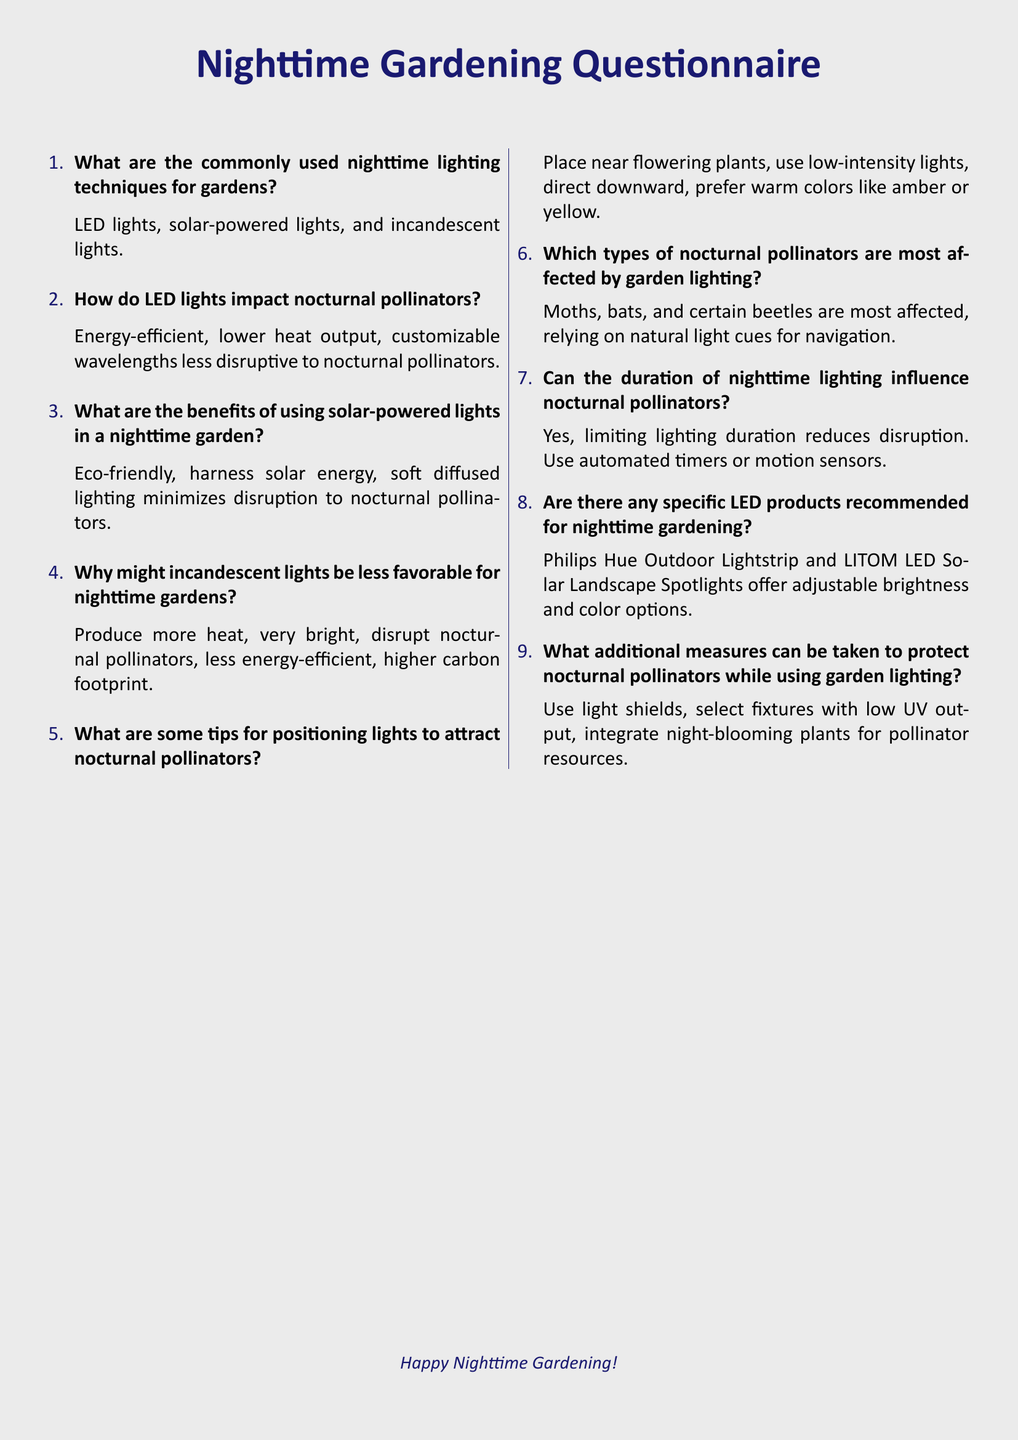What are the commonly used nighttime lighting techniques for gardens? The document lists the commonly used nighttime lighting techniques for gardens, which include LED lights, solar-powered lights, and incandescent lights.
Answer: LED lights, solar-powered lights, and incandescent lights How do LED lights impact nocturnal pollinators? The document explains that LED lights are energy-efficient, produce lower heat output, and have customizable wavelengths that are less disruptive to nocturnal pollinators.
Answer: Energy-efficient, lower heat output, customizable wavelengths What are the benefits of using solar-powered lights in a nighttime garden? According to the document, the benefits of using solar-powered lights include being eco-friendly, harnessing solar energy, and providing soft diffused lighting that minimizes disruption to nocturnal pollinators.
Answer: Eco-friendly, harness solar energy, soft diffused lighting Why might incandescent lights be less favorable for nighttime gardens? The document states that incandescent lights produce more heat, are very bright, disrupt nocturnal pollinators, are less energy-efficient, and have a higher carbon footprint.
Answer: Produce more heat, very bright, disrupt nocturnal pollinators Which types of nocturnal pollinators are most affected by garden lighting? The document specifically mentions that moths, bats, and certain beetles are most affected by garden lighting as they rely on natural light cues for navigation.
Answer: Moths, bats, and certain beetles Can the duration of nighttime lighting influence nocturnal pollinators? The questionnaire indicates that limiting the duration of nighttime lighting reduces disruption to nocturnal pollinators, suggesting the use of automated timers or motion sensors.
Answer: Yes, limiting lighting duration reduces disruption Are there any specific LED products recommended for nighttime gardening? The document recommends specific LED products such as Philips Hue Outdoor Lightstrip and LITOM LED Solar Landscape Spotlights for nighttime gardening.
Answer: Philips Hue Outdoor Lightstrip and LITOM LED Solar Landscape Spotlights What additional measures can be taken to protect nocturnal pollinators while using garden lighting? The document mentions using light shields, selecting fixtures with low UV output, and integrating night-blooming plants as additional measures to protect nocturnal pollinators.
Answer: Use light shields, select fixtures with low UV output, integrate night-blooming plants 